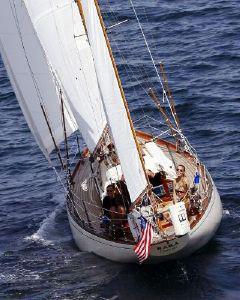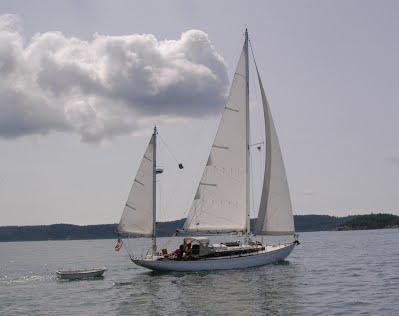The first image is the image on the left, the second image is the image on the right. For the images shown, is this caption "The ship in the right image is sailing in front of a land bar" true? Answer yes or no. Yes. The first image is the image on the left, the second image is the image on the right. Evaluate the accuracy of this statement regarding the images: "The left and right image contains the same number of sailboats with three open sails.". Is it true? Answer yes or no. Yes. 